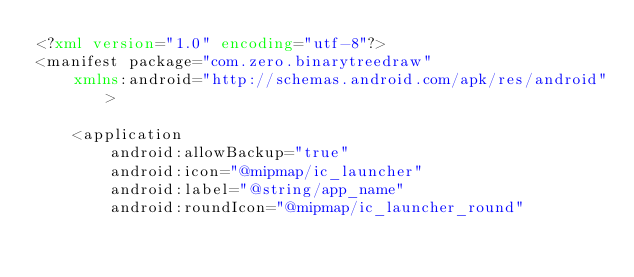Convert code to text. <code><loc_0><loc_0><loc_500><loc_500><_XML_><?xml version="1.0" encoding="utf-8"?>
<manifest package="com.zero.binarytreedraw"
    xmlns:android="http://schemas.android.com/apk/res/android">

    <application
        android:allowBackup="true"
        android:icon="@mipmap/ic_launcher"
        android:label="@string/app_name"
        android:roundIcon="@mipmap/ic_launcher_round"</code> 